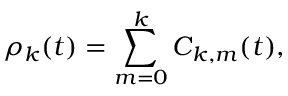<formula> <loc_0><loc_0><loc_500><loc_500>\rho _ { k } ( t ) = \sum _ { m = 0 } ^ { k } C _ { k , m } ( t ) ,</formula> 